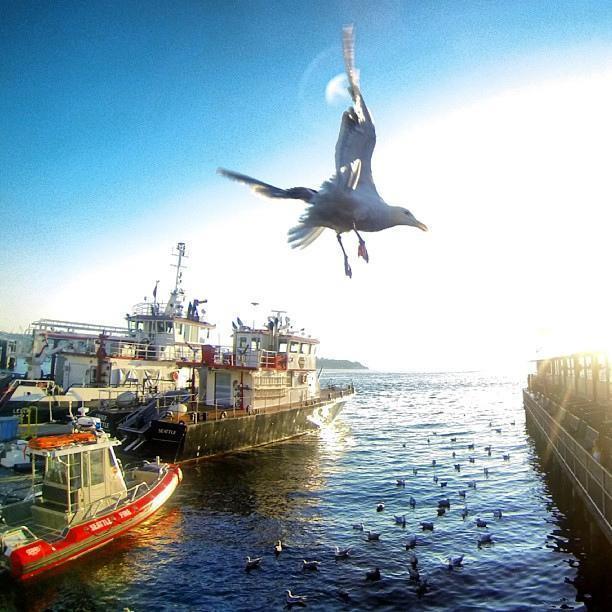How many boats are there?
Give a very brief answer. 4. How many birds are there?
Give a very brief answer. 2. 